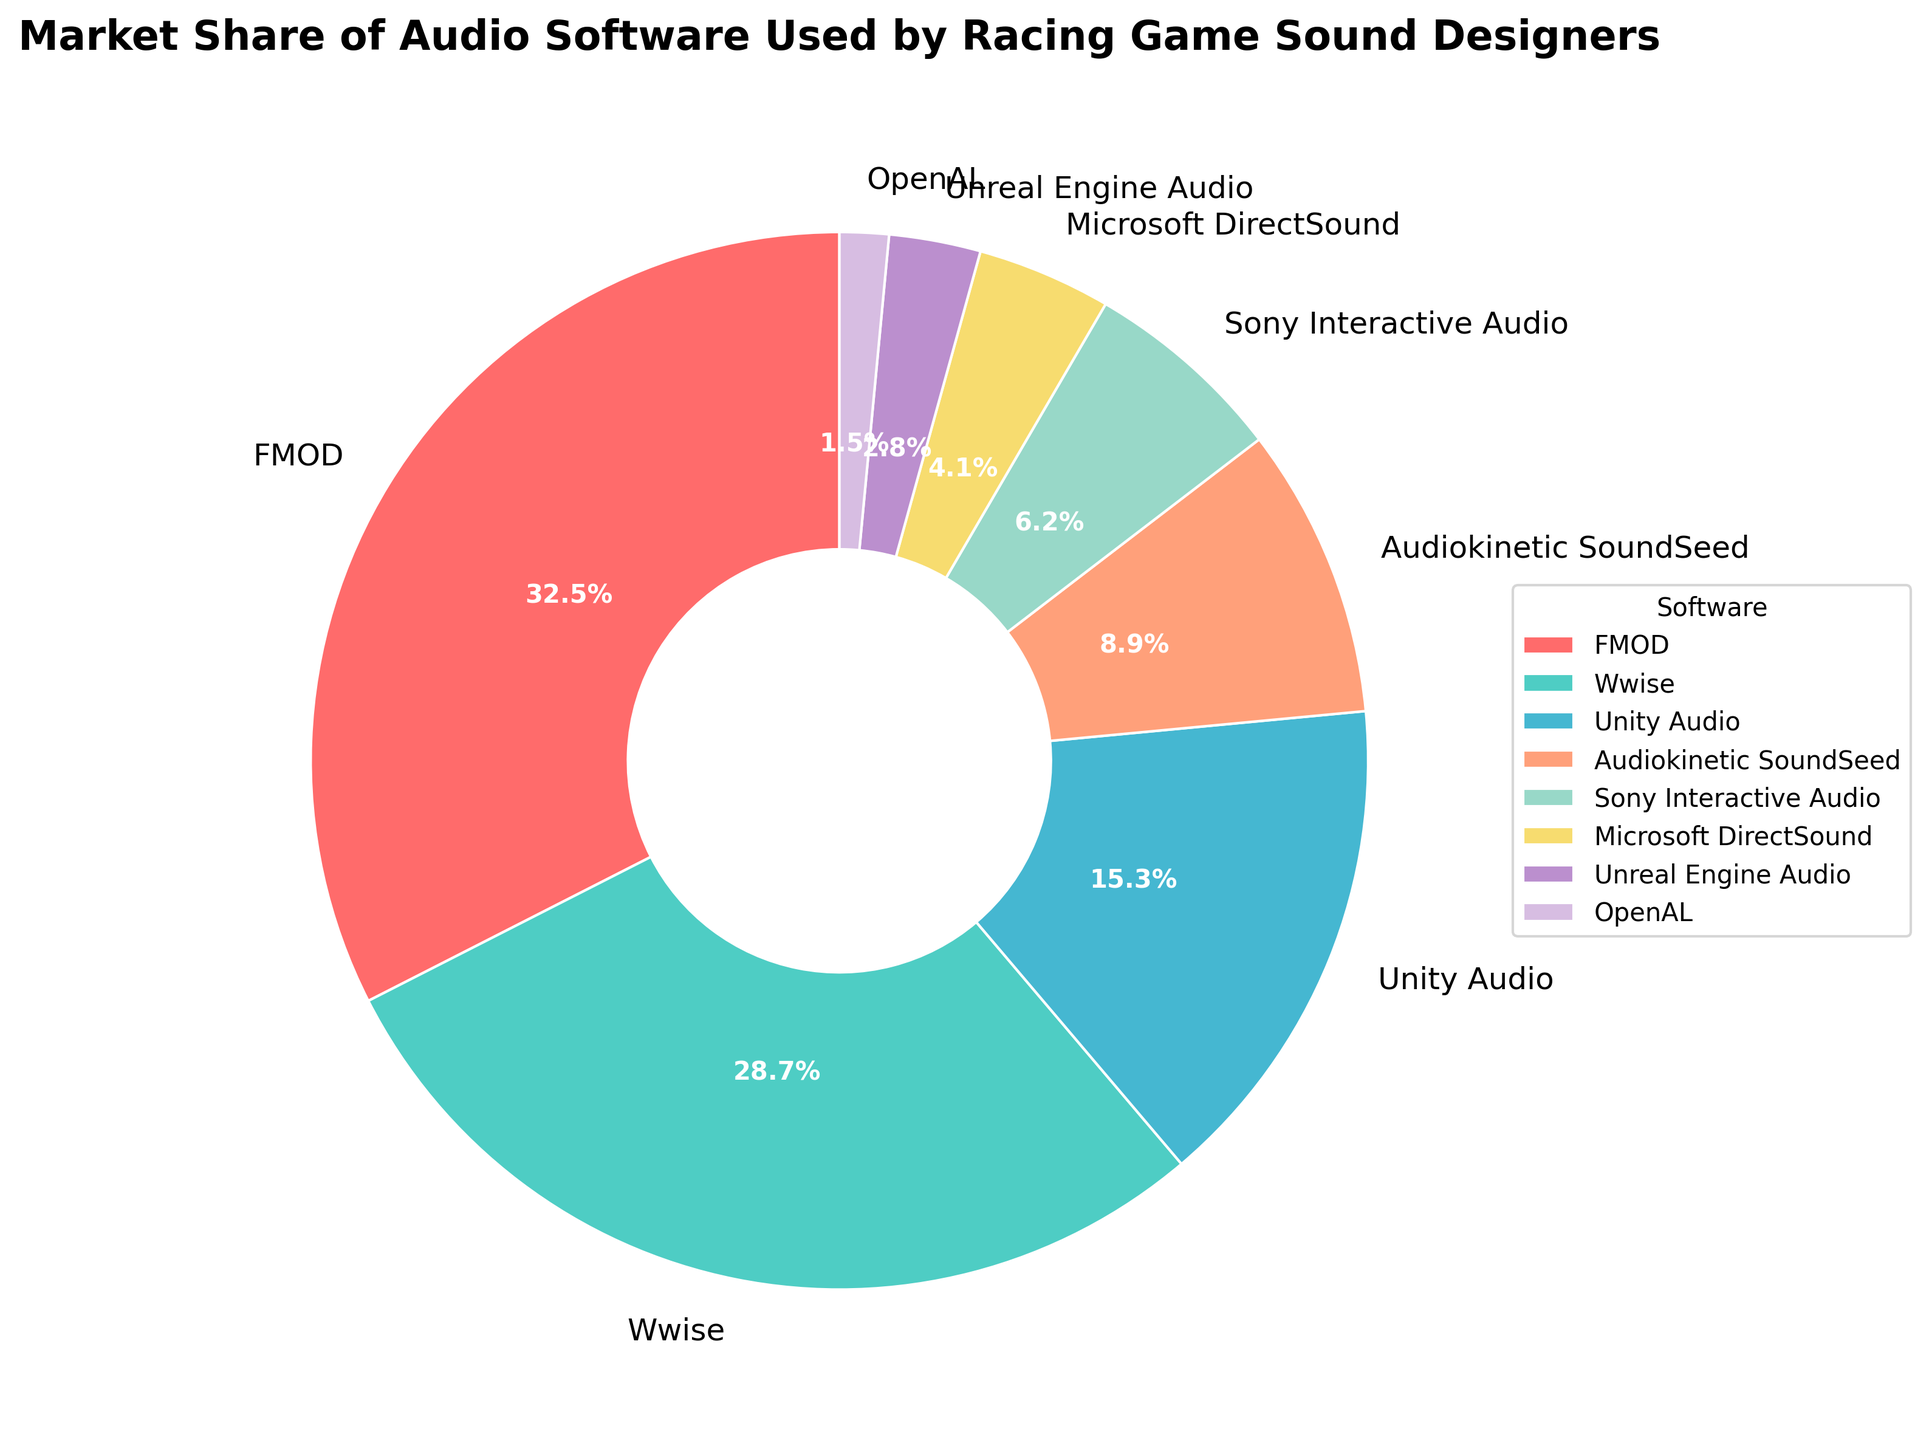Which software has the largest market share? Identify the segment with the largest percentage indicated by the percentage labels on the pie chart. FMOD is labeled with the highest value of 32.5%.
Answer: FMOD Which two softwares together make up more than 60% of the market share? Sum the market shares of the largest segments until their total exceeds 60%. FMOD (32.5%) + Wwise (28.7%) = 61.2%.
Answer: FMOD and Wwise What is the combined market share of Unity Audio and Audiokinetic SoundSeed? Add the market shares of Unity Audio (15.3%) and Audiokinetic SoundSeed (8.9%). The combined value is 15.3 + 8.9 = 24.2%.
Answer: 24.2% How much smaller is Microsoft DirectSound's market share compared to Sony Interactive Audio's market share? Subtract Microsoft DirectSound's market share (4.1%) from Sony Interactive Audio's market share (6.2%). The difference is 6.2 - 4.1 = 2.1%.
Answer: 2.1% Which software has the smallest market share and what is the percentage? Identify the segment with the smallest percentage indicated by the labels. OpenAL is labeled with 1.5%, which is the smallest value.
Answer: OpenAL, 1.5% How do the combined market shares of Microsoft DirectSound and Unreal Engine Audio compare to Sony Interactive Audio? Sum the market shares of Microsoft DirectSound (4.1%) and Unreal Engine Audio (2.8%), then compare to Sony Interactive Audio (6.2%). The combined value is 4.1 + 2.8 = 6.9%, which is slightly higher than 6.2%.
Answer: 6.9% (higher) What is the difference in market share between the top software and the third highest software? Subtract Unity Audio's market share (15.3%) from FMOD's market share (32.5%). The difference is 32.5 - 15.3 = 17.2%.
Answer: 17.2% What portion of the market is held by softwares with less than 10% market share each? Sum the market shares of Audiokinetic SoundSeed (8.9%), Sony Interactive Audio (6.2%), Microsoft DirectSound (4.1%), Unreal Engine Audio (2.8%), and OpenAL (1.5%). The combined value is 8.9 + 6.2 + 4.1 + 2.8 + 1.5 = 23.5%.
Answer: 23.5% Between FMOD and Wwise, which one has a larger market share and by how much? Compare the market shares of FMOD (32.5%) and Wwise (28.7%), and subtract Wwise's share from FMOD's share. The difference is 32.5 - 28.7 = 3.8%.
Answer: FMOD, 3.8% 